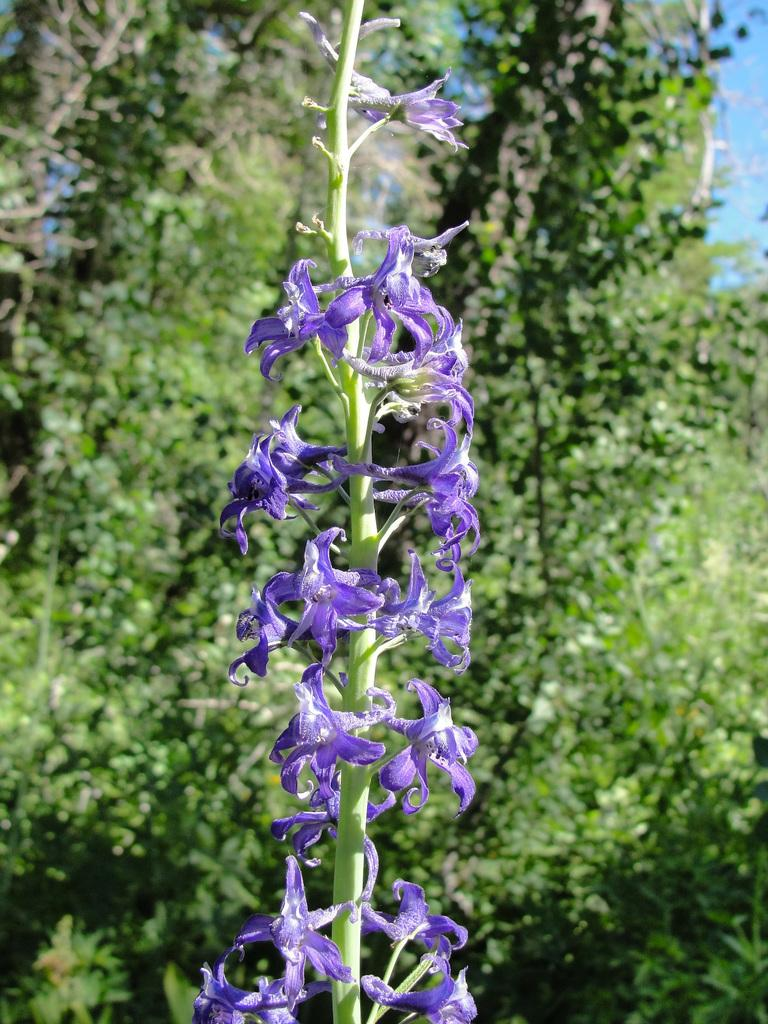What type of flowers are present in the image? There are violet color flowers on a stem in the image. What can be seen in the background of the image? There are trees in the background of the image. What type of comb is being used to style the flowers in the image? There is no comb present in the image, as it features flowers on a stem and trees in the background. 